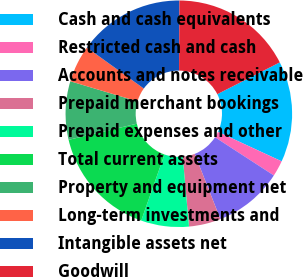<chart> <loc_0><loc_0><loc_500><loc_500><pie_chart><fcel>Cash and cash equivalents<fcel>Restricted cash and cash<fcel>Accounts and notes receivable<fcel>Prepaid merchant bookings<fcel>Prepaid expenses and other<fcel>Total current assets<fcel>Property and equipment net<fcel>Long-term investments and<fcel>Intangible assets net<fcel>Goodwill<nl><fcel>14.39%<fcel>2.27%<fcel>9.85%<fcel>4.55%<fcel>6.82%<fcel>15.91%<fcel>8.33%<fcel>5.3%<fcel>15.15%<fcel>17.42%<nl></chart> 